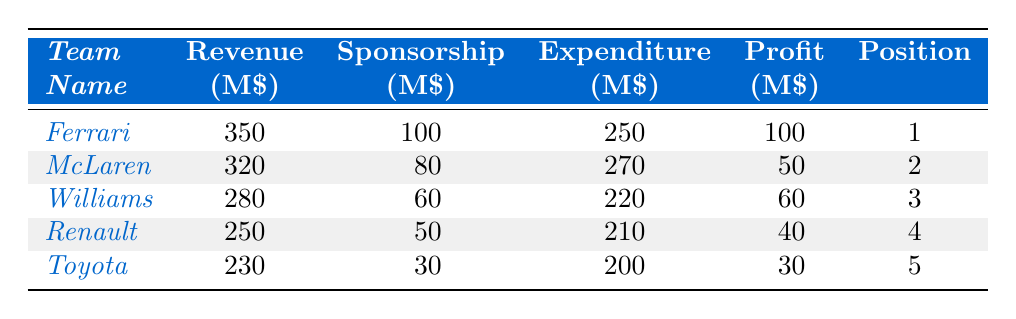What was the revenue of Ferrari? The table shows the revenue for Ferrari listed as 350 million USD.
Answer: 350 million USD Which team had the highest profit? By comparing the profit values in the table, Ferrari has the highest profit at 100 million USD.
Answer: Ferrari What was the expenditure of McLaren? The expenditure for McLaren is indicated as 270 million USD in the table.
Answer: 270 million USD Which team generated more revenue: Toyota or Renault? Toyota's revenue is 230 million USD, while Renault's revenue is 250 million USD. Therefore, Renault generated more revenue.
Answer: Renault How much did Williams profit compared to Toyota? Williams had a profit of 60 million USD and Toyota had a profit of 30 million USD. The difference is 60 - 30 = 30 million USD.
Answer: Williams profited 30 million USD more than Toyota What is the average sponsorship revenue of the top five teams? To find the average, sum the sponsorship values: 100 + 80 + 60 + 50 + 30 = 320. Then divide by 5: 320 / 5 = 64 million USD.
Answer: 64 million USD Is it true that McLaren spent more than Ferrari? McLaren’s expenditure is 270 million USD, while Ferrari’s expenditure is 250 million USD. Thus, it is true that McLaren spent more.
Answer: Yes What is the total revenue of the top three teams combined? The total revenue for the top three teams is calculated by summing their revenues: 350 (Ferrari) + 320 (McLaren) + 280 (Williams) = 950 million USD.
Answer: 950 million USD Which team had the lowest position and what was its profit? The team with the lowest position is Toyota, which finished fifth, and its profit was 30 million USD.
Answer: Toyota, 30 million USD By how much did Ferrari's profits exceed Renault's profits? Ferrari’s profit is 100 million USD and Renault's profit is 40 million USD. The difference is 100 - 40 = 60 million USD.
Answer: 60 million USD 